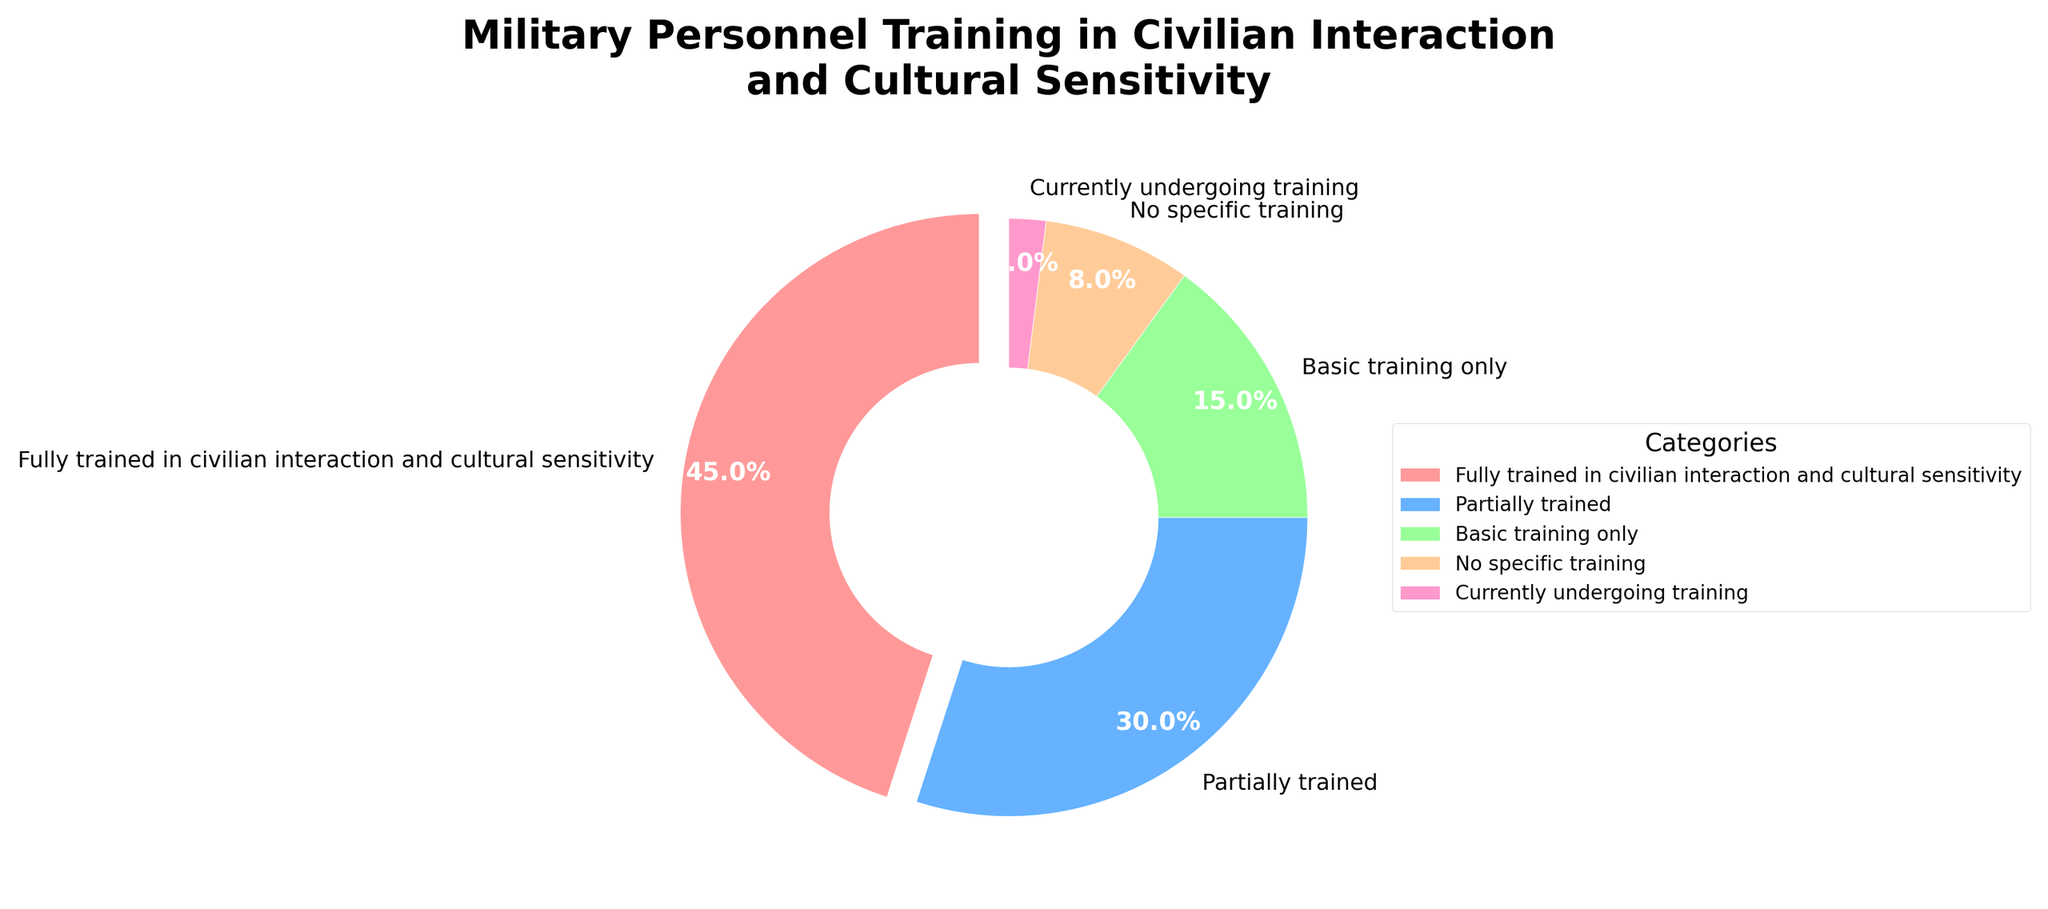What category has the largest percentage of military personnel? The pie chart shows five categories, and the category labeled as "Fully trained in civilian interaction and cultural sensitivity" occupies the largest portion of the pie.
Answer: Fully trained in civilian interaction and cultural sensitivity How many categories of training are shown in the pie chart? The pie chart displays wedges for each category. Counting the labels indicates there are five distinct categories.
Answer: Five What is the combined percentage of military personnel with no specific training and those currently undergoing training? Add the percentages for the categories "No specific training" and "Currently undergoing training". The sum is 8% + 2%.
Answer: 10% Which training category contributes less than 10% to the total? Examining the pie chart, the category labeled "Currently undergoing training" occupies a small section, noted as 2%.
Answer: Currently undergoing training What is the difference in percentage between those fully trained and those with basic training only? Subtract the percentage of the "Basic training only" category from the "Fully trained in civilian interaction and cultural sensitivity" category. The calculation is 45% - 15%.
Answer: 30% Which categories together constitute more than half of the total percentage? Summing the percentages of different combinations, we find that "Fully trained in civilian interaction and cultural sensitivity" (45%) and "Partially trained" (30%) together make 75%, which is more than half.
Answer: Fully trained in civilian interaction and cultural sensitivity, Partially trained What color represents the "Basic training only" category in the pie chart? The wedges are colored differently, and each color corresponds to a specific category. The "Basic training only" section is colored green.
Answer: Green Which category of training has the second-highest percentage of military personnel? The pie chart indicates that the second-largest wedge is labeled "Partially trained," corresponding to 30%.
Answer: Partially trained Is the percentage of fully trained personnel greater than the combined percentage of those with no specific training and basic training only? Calculate the combined percentage of "No specific training" and "Basic training only" which is 8% + 15% = 23%. Compare it to 45%.
Answer: Yes What portion of the total percentage is occupied by personnel who received partial training? The pie chart prominently displays labels for each category's wedge. The label for "Partially trained" shows 30%.
Answer: 30% 